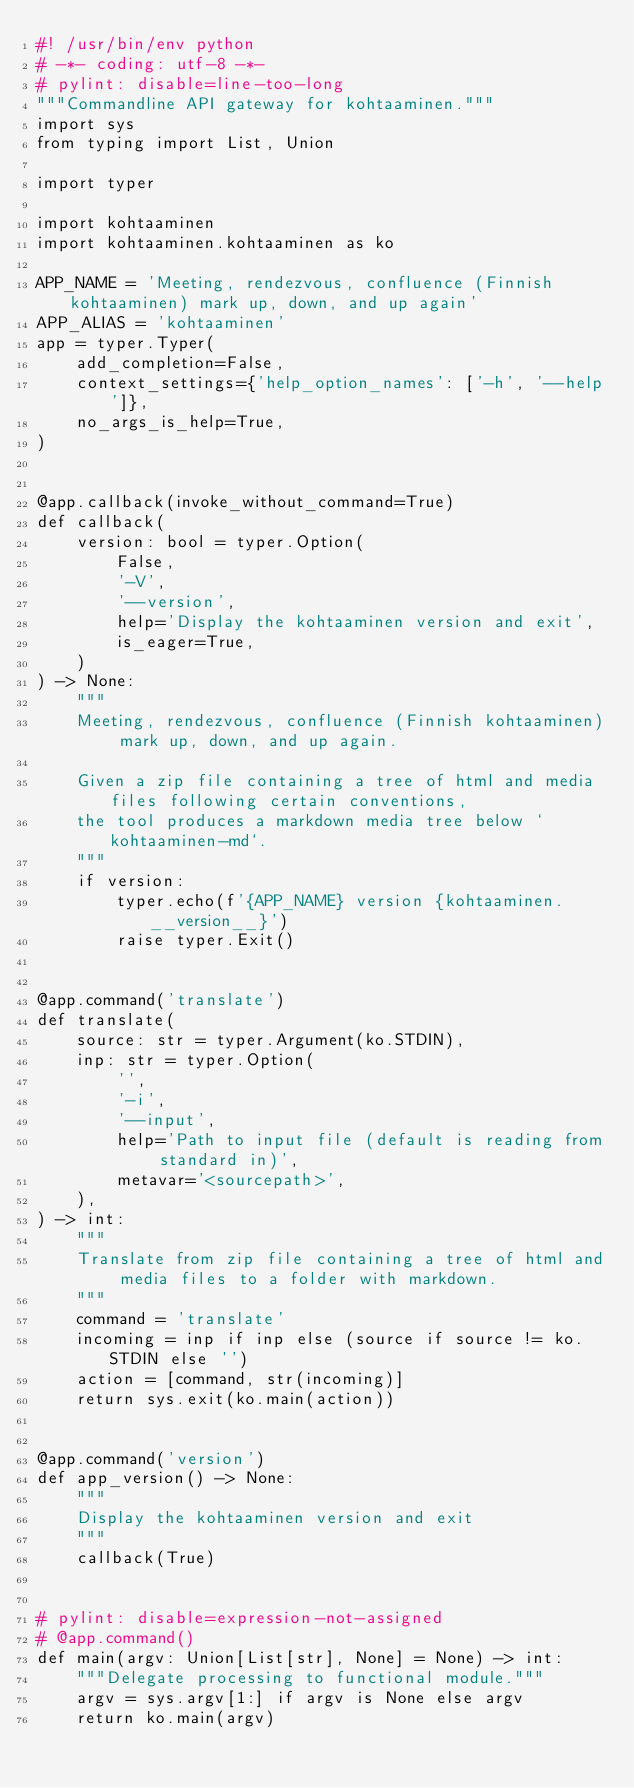<code> <loc_0><loc_0><loc_500><loc_500><_Python_>#! /usr/bin/env python
# -*- coding: utf-8 -*-
# pylint: disable=line-too-long
"""Commandline API gateway for kohtaaminen."""
import sys
from typing import List, Union

import typer

import kohtaaminen
import kohtaaminen.kohtaaminen as ko

APP_NAME = 'Meeting, rendezvous, confluence (Finnish kohtaaminen) mark up, down, and up again'
APP_ALIAS = 'kohtaaminen'
app = typer.Typer(
    add_completion=False,
    context_settings={'help_option_names': ['-h', '--help']},
    no_args_is_help=True,
)


@app.callback(invoke_without_command=True)
def callback(
    version: bool = typer.Option(
        False,
        '-V',
        '--version',
        help='Display the kohtaaminen version and exit',
        is_eager=True,
    )
) -> None:
    """
    Meeting, rendezvous, confluence (Finnish kohtaaminen) mark up, down, and up again.

    Given a zip file containing a tree of html and media files following certain conventions,
    the tool produces a markdown media tree below `kohtaaminen-md`.
    """
    if version:
        typer.echo(f'{APP_NAME} version {kohtaaminen.__version__}')
        raise typer.Exit()


@app.command('translate')
def translate(
    source: str = typer.Argument(ko.STDIN),
    inp: str = typer.Option(
        '',
        '-i',
        '--input',
        help='Path to input file (default is reading from standard in)',
        metavar='<sourcepath>',
    ),
) -> int:
    """
    Translate from zip file containing a tree of html and media files to a folder with markdown.
    """
    command = 'translate'
    incoming = inp if inp else (source if source != ko.STDIN else '')
    action = [command, str(incoming)]
    return sys.exit(ko.main(action))


@app.command('version')
def app_version() -> None:
    """
    Display the kohtaaminen version and exit
    """
    callback(True)


# pylint: disable=expression-not-assigned
# @app.command()
def main(argv: Union[List[str], None] = None) -> int:
    """Delegate processing to functional module."""
    argv = sys.argv[1:] if argv is None else argv
    return ko.main(argv)
</code> 